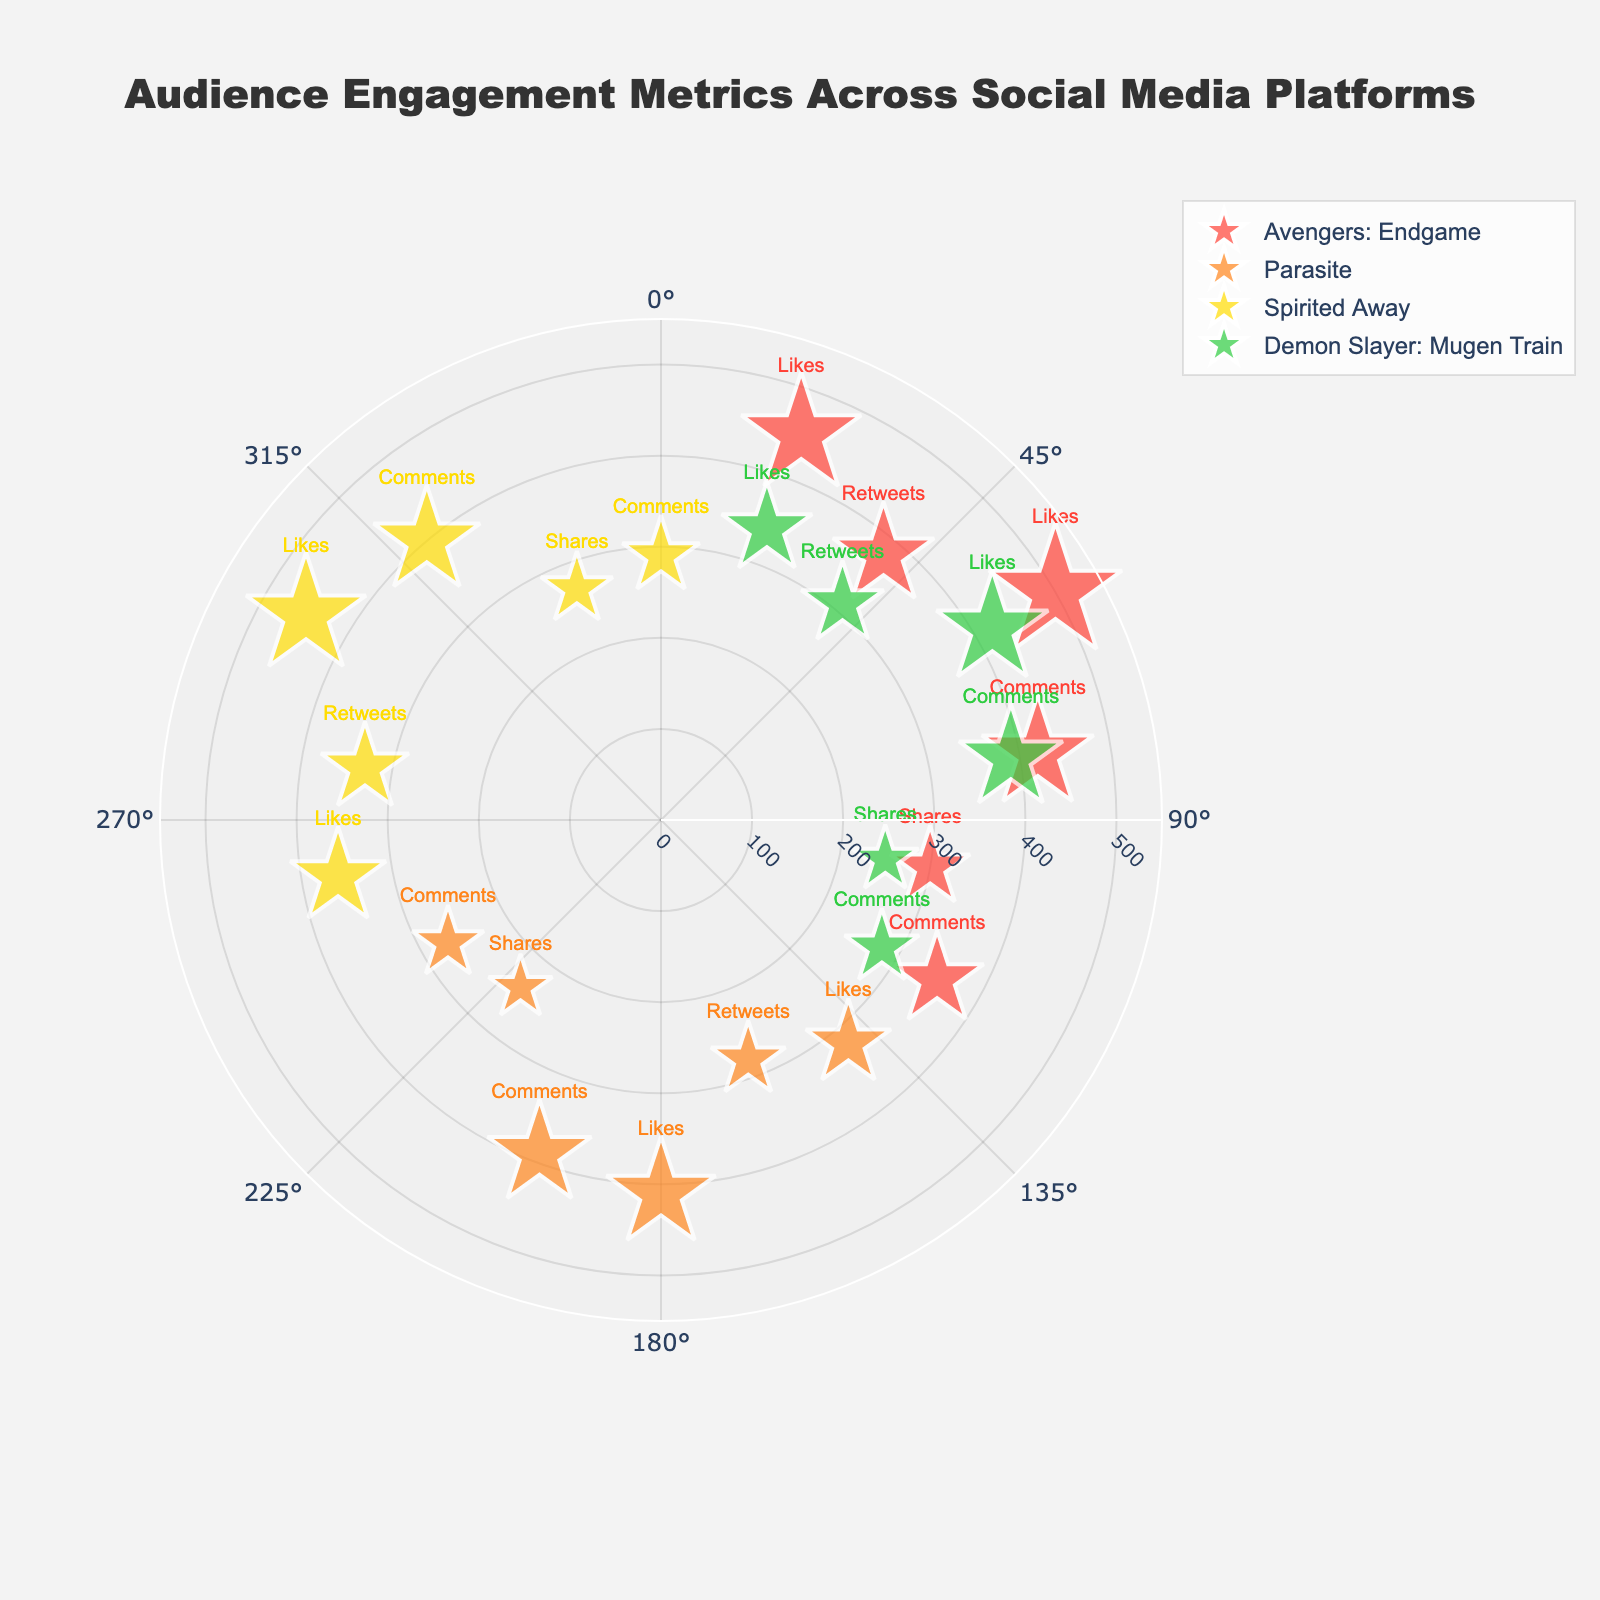What is the engagement metric with the highest radius for "Avengers: Endgame"? Look for the largest data point in terms of radius for "Avengers: Endgame". On the chart, "Instagram Likes" has a radius of 500, which is the highest.
Answer: Instagram Likes Which film has the highest radius engagement metric overall? Check each film's individual data points to identify the one with the highest radius. "Avengers: Endgame" with "Instagram Likes" at a radius of 500 is the highest.
Answer: Avengers: Endgame Between Twitter Likes and Instagram Likes for "Spirited Away", which has higher engagement? Compare the radii of "Twitter Likes" and "Instagram Likes" points for "Spirited Away". "Instagram Likes" with a radius of 450 is higher than "Twitter Likes" with a radius of 360.
Answer: Instagram Likes What is the total number of data points for "Parasite"? Count all the data points related to "Parasite" in the chart. There are 6 data points (Likes and Retweets on Twitter, Likes and Comments on Instagram, Shares and Comments on Facebook).
Answer: 6 Which social media platform has the lowest engagement for "Demon Slayer: Mugen Train"? Identify the platform with the smallest radius data point for "Demon Slayer: Mugen Train". The lowest engagement is on "Facebook Shares" with a radius of 250.
Answer: Facebook Shares 